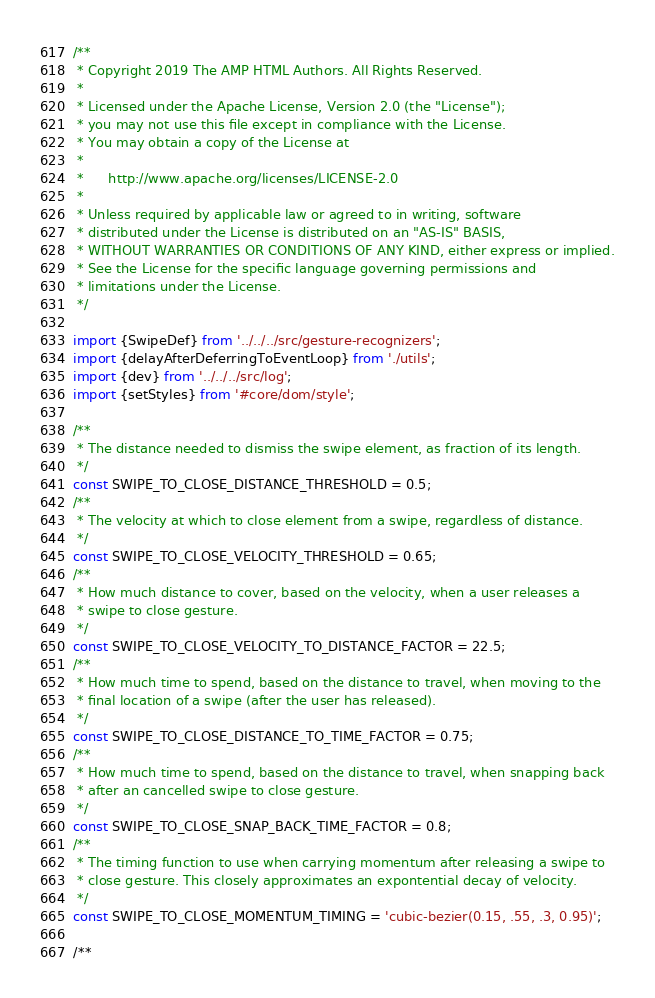Convert code to text. <code><loc_0><loc_0><loc_500><loc_500><_JavaScript_>/**
 * Copyright 2019 The AMP HTML Authors. All Rights Reserved.
 *
 * Licensed under the Apache License, Version 2.0 (the "License");
 * you may not use this file except in compliance with the License.
 * You may obtain a copy of the License at
 *
 *      http://www.apache.org/licenses/LICENSE-2.0
 *
 * Unless required by applicable law or agreed to in writing, software
 * distributed under the License is distributed on an "AS-IS" BASIS,
 * WITHOUT WARRANTIES OR CONDITIONS OF ANY KIND, either express or implied.
 * See the License for the specific language governing permissions and
 * limitations under the License.
 */

import {SwipeDef} from '../../../src/gesture-recognizers';
import {delayAfterDeferringToEventLoop} from './utils';
import {dev} from '../../../src/log';
import {setStyles} from '#core/dom/style';

/**
 * The distance needed to dismiss the swipe element, as fraction of its length.
 */
const SWIPE_TO_CLOSE_DISTANCE_THRESHOLD = 0.5;
/**
 * The velocity at which to close element from a swipe, regardless of distance.
 */
const SWIPE_TO_CLOSE_VELOCITY_THRESHOLD = 0.65;
/**
 * How much distance to cover, based on the velocity, when a user releases a
 * swipe to close gesture.
 */
const SWIPE_TO_CLOSE_VELOCITY_TO_DISTANCE_FACTOR = 22.5;
/**
 * How much time to spend, based on the distance to travel, when moving to the
 * final location of a swipe (after the user has released).
 */
const SWIPE_TO_CLOSE_DISTANCE_TO_TIME_FACTOR = 0.75;
/**
 * How much time to spend, based on the distance to travel, when snapping back
 * after an cancelled swipe to close gesture.
 */
const SWIPE_TO_CLOSE_SNAP_BACK_TIME_FACTOR = 0.8;
/**
 * The timing function to use when carrying momentum after releasing a swipe to
 * close gesture. This closely approximates an expontential decay of velocity.
 */
const SWIPE_TO_CLOSE_MOMENTUM_TIMING = 'cubic-bezier(0.15, .55, .3, 0.95)';

/**</code> 